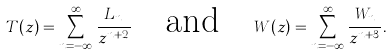Convert formula to latex. <formula><loc_0><loc_0><loc_500><loc_500>T ( z ) = \sum _ { n = - \infty } ^ { \infty } \frac { L _ { n } } { z ^ { n + 2 } } \quad \text {and} \quad W ( z ) = \sum _ { n = - \infty } ^ { \infty } \frac { W _ { n } } { z ^ { n + 3 } } .</formula> 